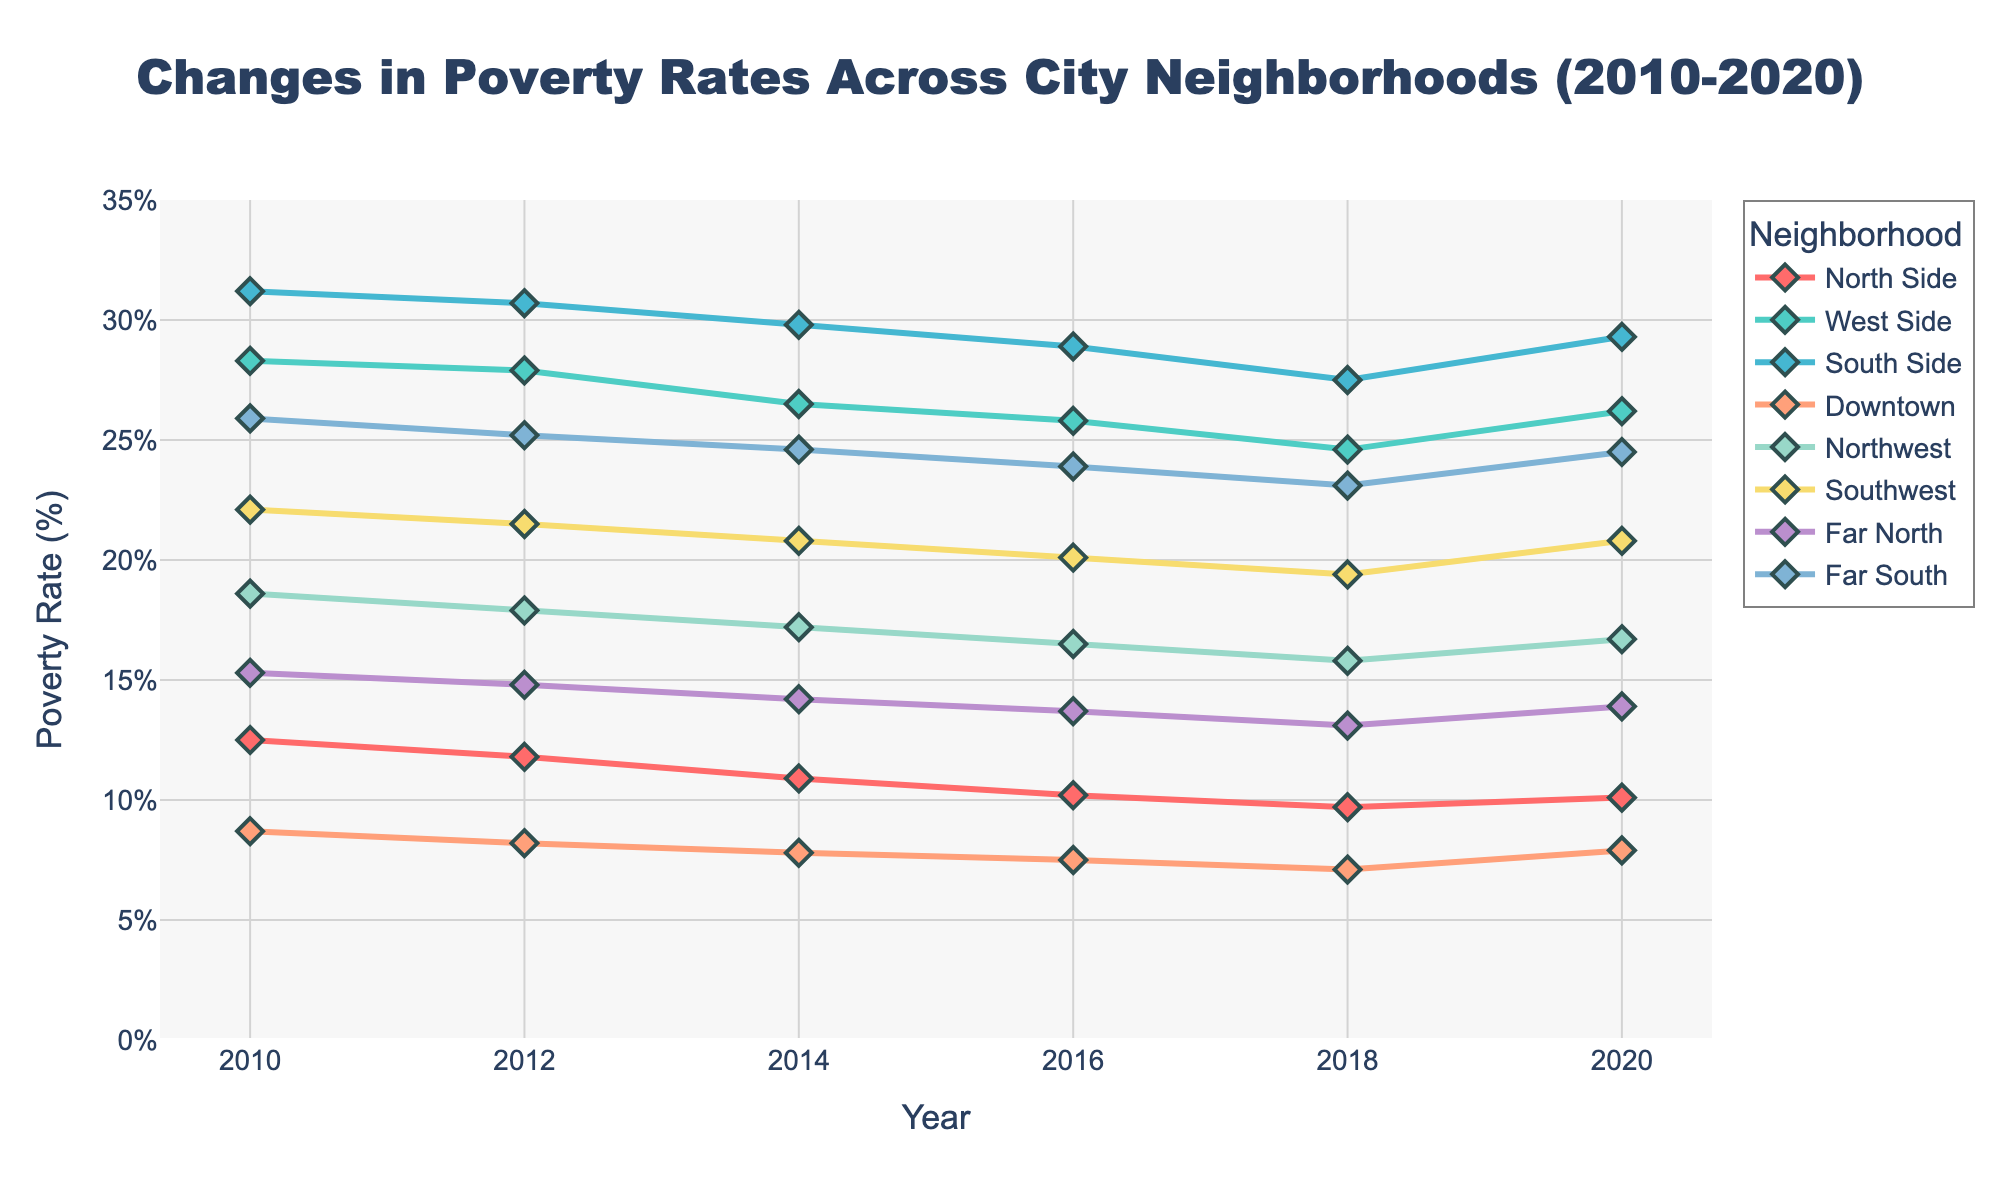What neighborhood had the highest poverty rate in 2010? In the 2010 column, the highest value is 31.2% which corresponds to the South Side.
Answer: South Side Which neighborhood showed the greatest reduction in poverty rate between 2010 and 2018? Calculate the difference between the 2010 and 2018 poverty rates for each neighborhood. The greatest reduction is for the South Side with a reduction of 31.2% - 27.5% = 3.7%.
Answer: South Side Which neighborhood had an increase in poverty rate from 2018 to 2020? Compare the 2018 and 2020 values for each neighborhood. The neighborhoods with increases are North Side, West Side, South Side, Northwest, Southwest, and Far South.
Answer: Multiple neighborhoods How did the poverty rate of Downtown change from 2010 to 2020? Compare the values for Downtown in 2010 and 2020. The rate decreased from 8.7% in 2010 to 7.9% in 2020.
Answer: Decreased Which neighborhood consistently had the lowest poverty rate from 2010 to 2020? Compare the poverty rates across all years for each neighborhood. Downtown consistently had the lowest rates.
Answer: Downtown What is the overall trend observed for the West Side's poverty rate? Look at the data for West Side from 2010 to 2020. There is a general decreasing trend from 28.3% in 2010 to 26.2% in 2020, despite a small increase towards the end.
Answer: Decreasing Between 2012 and 2020, which neighborhood had the smallest variability in poverty rates? Check the differences for each neighborhood between 2012 and 2020. Downtown shows the smallest variability as the values change from 8.2% to 7.9%.
Answer: Downtown What is the average poverty rate of North Side from 2010 to 2020? Sum the values for North Side across all years and divide by the number of years: (12.5 + 11.8 + 10.9 + 10.2 + 9.7 + 10.1) / 6 = 10.87%.
Answer: 10.87% Which neighborhood had a poverty rate closest to 15% in 2012? Compare the 2012 values to 15%. Far North had a rate of 14.8%, which is closest to 15%.
Answer: Far North What was the percent change in the poverty rate for the Far South from 2016 to 2020? Calculate the percentage change using the formula ((new value - old value) / old value) * 100. For Far South, ((24.5 - 23.9) / 23.9) * 100 = 2.51%.
Answer: 2.51% 